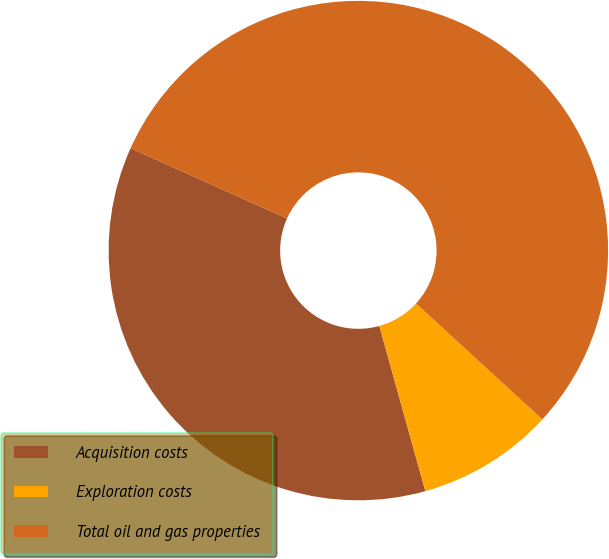Convert chart. <chart><loc_0><loc_0><loc_500><loc_500><pie_chart><fcel>Acquisition costs<fcel>Exploration costs<fcel>Total oil and gas properties<nl><fcel>36.05%<fcel>8.86%<fcel>55.09%<nl></chart> 